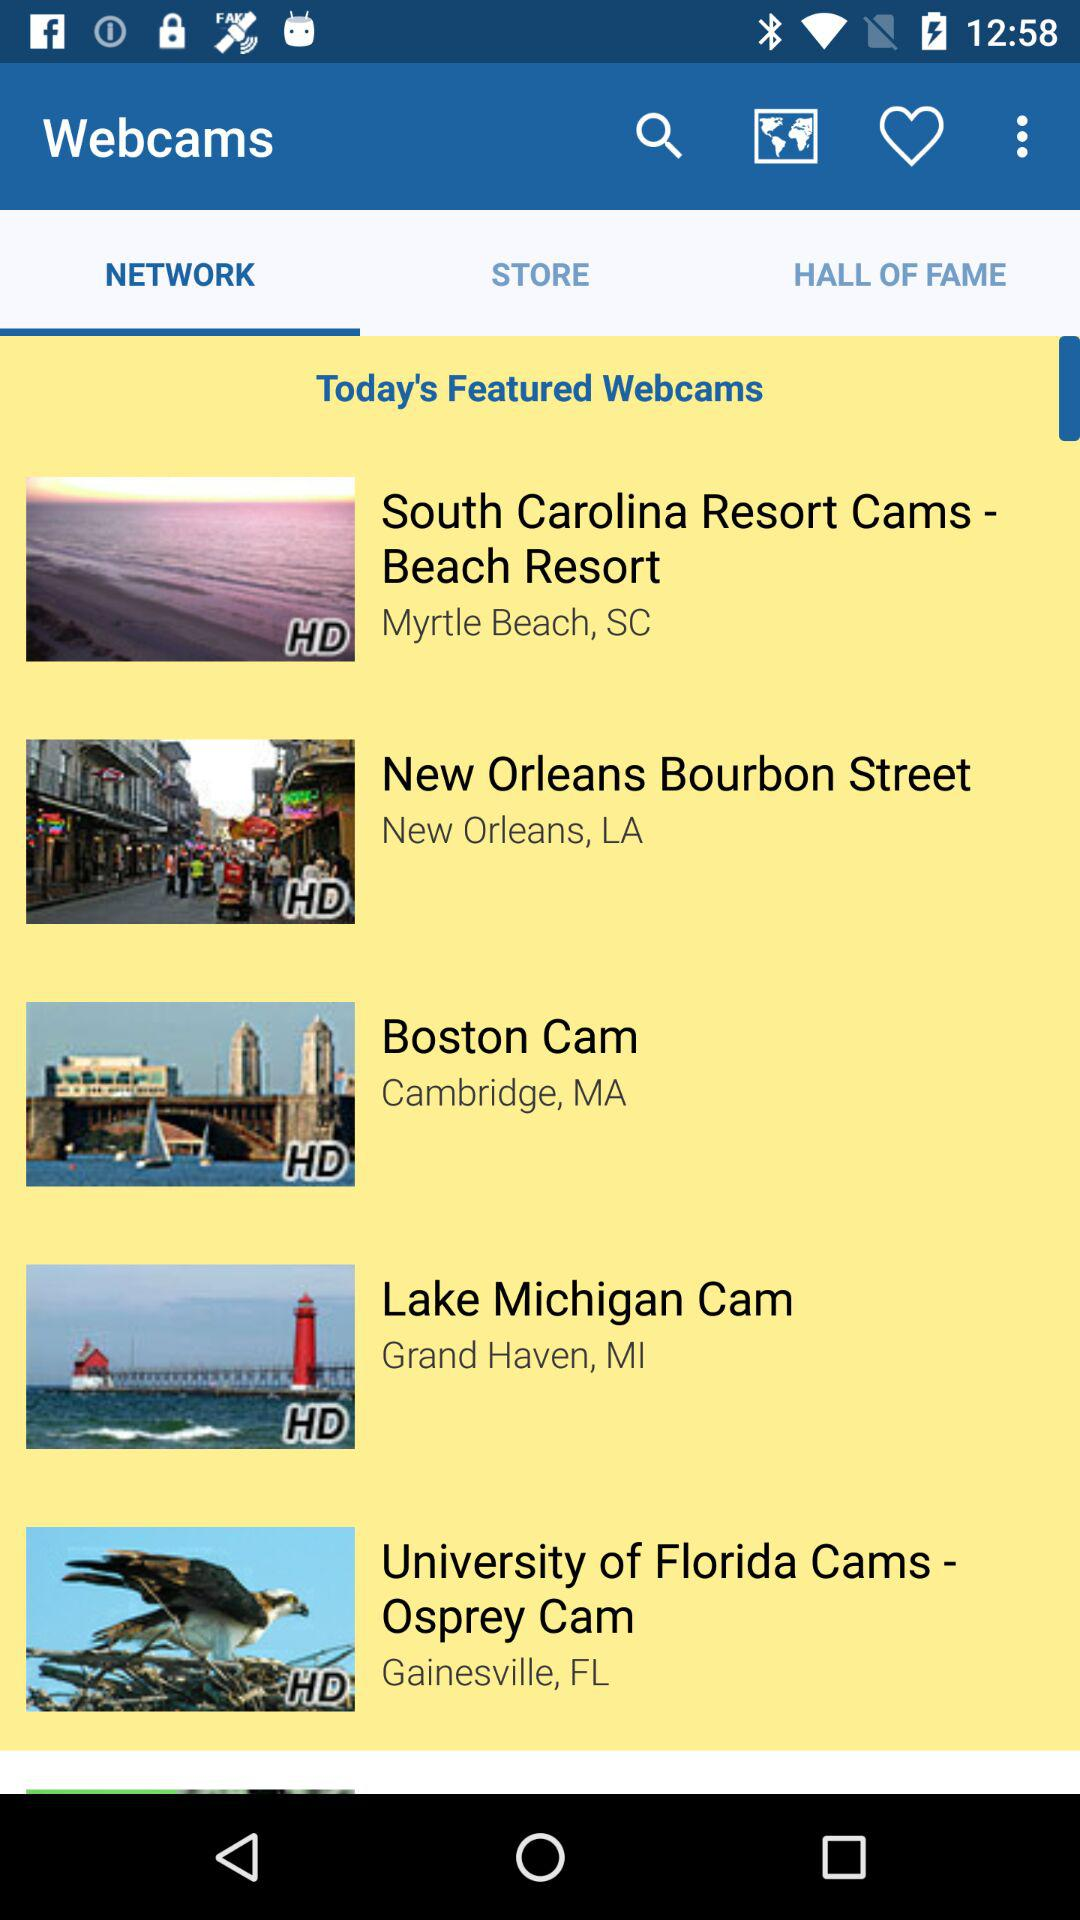What is the location of "Lake Michigan Cam"? The location of "Lake Michigan Cam" is Grand Haven, MI. 